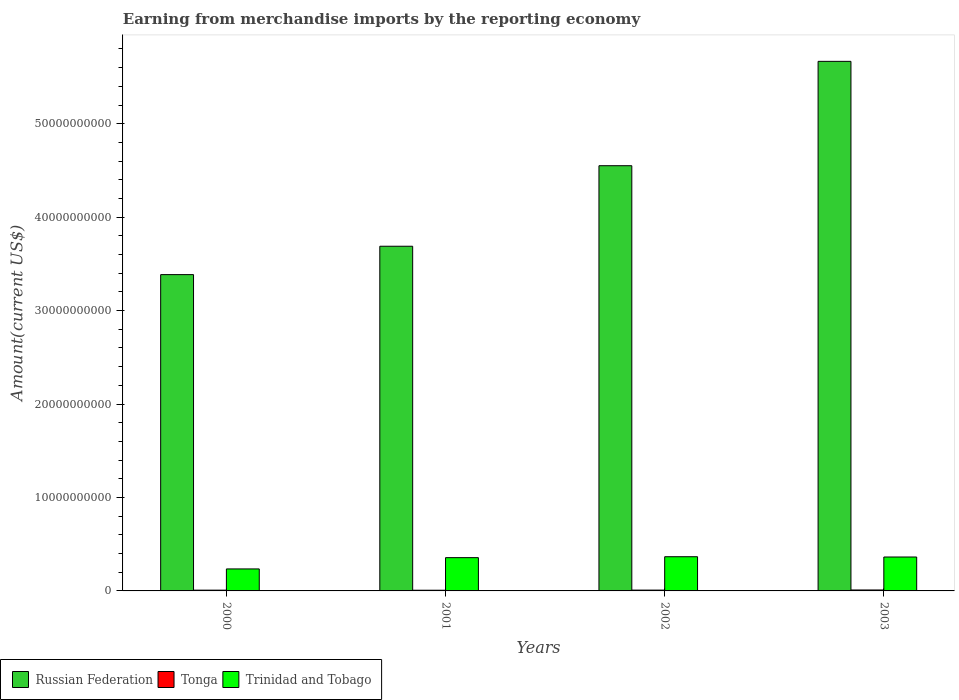How many different coloured bars are there?
Keep it short and to the point. 3. How many bars are there on the 4th tick from the left?
Make the answer very short. 3. What is the amount earned from merchandise imports in Tonga in 2002?
Provide a short and direct response. 8.71e+07. Across all years, what is the maximum amount earned from merchandise imports in Trinidad and Tobago?
Give a very brief answer. 3.66e+09. Across all years, what is the minimum amount earned from merchandise imports in Trinidad and Tobago?
Provide a short and direct response. 2.35e+09. What is the total amount earned from merchandise imports in Russian Federation in the graph?
Make the answer very short. 1.73e+11. What is the difference between the amount earned from merchandise imports in Tonga in 2002 and that in 2003?
Provide a succinct answer. -1.44e+07. What is the difference between the amount earned from merchandise imports in Trinidad and Tobago in 2001 and the amount earned from merchandise imports in Tonga in 2002?
Provide a succinct answer. 3.47e+09. What is the average amount earned from merchandise imports in Tonga per year?
Provide a succinct answer. 8.63e+07. In the year 2002, what is the difference between the amount earned from merchandise imports in Trinidad and Tobago and amount earned from merchandise imports in Tonga?
Ensure brevity in your answer.  3.57e+09. What is the ratio of the amount earned from merchandise imports in Tonga in 2002 to that in 2003?
Provide a succinct answer. 0.86. Is the difference between the amount earned from merchandise imports in Trinidad and Tobago in 2000 and 2003 greater than the difference between the amount earned from merchandise imports in Tonga in 2000 and 2003?
Provide a succinct answer. No. What is the difference between the highest and the second highest amount earned from merchandise imports in Trinidad and Tobago?
Provide a succinct answer. 3.12e+07. What is the difference between the highest and the lowest amount earned from merchandise imports in Trinidad and Tobago?
Offer a very short reply. 1.31e+09. In how many years, is the amount earned from merchandise imports in Trinidad and Tobago greater than the average amount earned from merchandise imports in Trinidad and Tobago taken over all years?
Make the answer very short. 3. Is the sum of the amount earned from merchandise imports in Russian Federation in 2001 and 2003 greater than the maximum amount earned from merchandise imports in Trinidad and Tobago across all years?
Your response must be concise. Yes. What does the 2nd bar from the left in 2001 represents?
Provide a short and direct response. Tonga. What does the 3rd bar from the right in 2000 represents?
Offer a very short reply. Russian Federation. Are all the bars in the graph horizontal?
Offer a very short reply. No. What is the difference between two consecutive major ticks on the Y-axis?
Offer a terse response. 1.00e+1. Are the values on the major ticks of Y-axis written in scientific E-notation?
Give a very brief answer. No. What is the title of the graph?
Your answer should be compact. Earning from merchandise imports by the reporting economy. What is the label or title of the X-axis?
Your answer should be compact. Years. What is the label or title of the Y-axis?
Keep it short and to the point. Amount(current US$). What is the Amount(current US$) of Russian Federation in 2000?
Your answer should be very brief. 3.39e+1. What is the Amount(current US$) of Tonga in 2000?
Offer a very short reply. 8.27e+07. What is the Amount(current US$) in Trinidad and Tobago in 2000?
Offer a very short reply. 2.35e+09. What is the Amount(current US$) in Russian Federation in 2001?
Provide a succinct answer. 3.69e+1. What is the Amount(current US$) in Tonga in 2001?
Provide a succinct answer. 7.39e+07. What is the Amount(current US$) of Trinidad and Tobago in 2001?
Offer a terse response. 3.56e+09. What is the Amount(current US$) of Russian Federation in 2002?
Offer a very short reply. 4.55e+1. What is the Amount(current US$) of Tonga in 2002?
Keep it short and to the point. 8.71e+07. What is the Amount(current US$) of Trinidad and Tobago in 2002?
Your response must be concise. 3.66e+09. What is the Amount(current US$) of Russian Federation in 2003?
Give a very brief answer. 5.67e+1. What is the Amount(current US$) in Tonga in 2003?
Keep it short and to the point. 1.01e+08. What is the Amount(current US$) in Trinidad and Tobago in 2003?
Your answer should be compact. 3.63e+09. Across all years, what is the maximum Amount(current US$) in Russian Federation?
Keep it short and to the point. 5.67e+1. Across all years, what is the maximum Amount(current US$) of Tonga?
Give a very brief answer. 1.01e+08. Across all years, what is the maximum Amount(current US$) of Trinidad and Tobago?
Your answer should be very brief. 3.66e+09. Across all years, what is the minimum Amount(current US$) in Russian Federation?
Ensure brevity in your answer.  3.39e+1. Across all years, what is the minimum Amount(current US$) of Tonga?
Give a very brief answer. 7.39e+07. Across all years, what is the minimum Amount(current US$) of Trinidad and Tobago?
Your response must be concise. 2.35e+09. What is the total Amount(current US$) in Russian Federation in the graph?
Provide a succinct answer. 1.73e+11. What is the total Amount(current US$) of Tonga in the graph?
Make the answer very short. 3.45e+08. What is the total Amount(current US$) of Trinidad and Tobago in the graph?
Ensure brevity in your answer.  1.32e+1. What is the difference between the Amount(current US$) in Russian Federation in 2000 and that in 2001?
Keep it short and to the point. -3.04e+09. What is the difference between the Amount(current US$) in Tonga in 2000 and that in 2001?
Your answer should be very brief. 8.82e+06. What is the difference between the Amount(current US$) of Trinidad and Tobago in 2000 and that in 2001?
Provide a succinct answer. -1.21e+09. What is the difference between the Amount(current US$) in Russian Federation in 2000 and that in 2002?
Keep it short and to the point. -1.17e+1. What is the difference between the Amount(current US$) in Tonga in 2000 and that in 2002?
Keep it short and to the point. -4.36e+06. What is the difference between the Amount(current US$) of Trinidad and Tobago in 2000 and that in 2002?
Your answer should be compact. -1.31e+09. What is the difference between the Amount(current US$) in Russian Federation in 2000 and that in 2003?
Offer a very short reply. -2.28e+1. What is the difference between the Amount(current US$) of Tonga in 2000 and that in 2003?
Make the answer very short. -1.88e+07. What is the difference between the Amount(current US$) of Trinidad and Tobago in 2000 and that in 2003?
Your answer should be compact. -1.28e+09. What is the difference between the Amount(current US$) of Russian Federation in 2001 and that in 2002?
Your response must be concise. -8.62e+09. What is the difference between the Amount(current US$) of Tonga in 2001 and that in 2002?
Provide a short and direct response. -1.32e+07. What is the difference between the Amount(current US$) in Trinidad and Tobago in 2001 and that in 2002?
Ensure brevity in your answer.  -9.90e+07. What is the difference between the Amount(current US$) in Russian Federation in 2001 and that in 2003?
Provide a succinct answer. -1.98e+1. What is the difference between the Amount(current US$) of Tonga in 2001 and that in 2003?
Your answer should be very brief. -2.76e+07. What is the difference between the Amount(current US$) of Trinidad and Tobago in 2001 and that in 2003?
Provide a short and direct response. -6.78e+07. What is the difference between the Amount(current US$) of Russian Federation in 2002 and that in 2003?
Your answer should be compact. -1.12e+1. What is the difference between the Amount(current US$) of Tonga in 2002 and that in 2003?
Ensure brevity in your answer.  -1.44e+07. What is the difference between the Amount(current US$) in Trinidad and Tobago in 2002 and that in 2003?
Keep it short and to the point. 3.12e+07. What is the difference between the Amount(current US$) of Russian Federation in 2000 and the Amount(current US$) of Tonga in 2001?
Ensure brevity in your answer.  3.38e+1. What is the difference between the Amount(current US$) in Russian Federation in 2000 and the Amount(current US$) in Trinidad and Tobago in 2001?
Offer a terse response. 3.03e+1. What is the difference between the Amount(current US$) of Tonga in 2000 and the Amount(current US$) of Trinidad and Tobago in 2001?
Provide a succinct answer. -3.48e+09. What is the difference between the Amount(current US$) in Russian Federation in 2000 and the Amount(current US$) in Tonga in 2002?
Offer a very short reply. 3.38e+1. What is the difference between the Amount(current US$) of Russian Federation in 2000 and the Amount(current US$) of Trinidad and Tobago in 2002?
Offer a terse response. 3.02e+1. What is the difference between the Amount(current US$) in Tonga in 2000 and the Amount(current US$) in Trinidad and Tobago in 2002?
Give a very brief answer. -3.58e+09. What is the difference between the Amount(current US$) in Russian Federation in 2000 and the Amount(current US$) in Tonga in 2003?
Your response must be concise. 3.38e+1. What is the difference between the Amount(current US$) in Russian Federation in 2000 and the Amount(current US$) in Trinidad and Tobago in 2003?
Provide a short and direct response. 3.02e+1. What is the difference between the Amount(current US$) of Tonga in 2000 and the Amount(current US$) of Trinidad and Tobago in 2003?
Ensure brevity in your answer.  -3.55e+09. What is the difference between the Amount(current US$) of Russian Federation in 2001 and the Amount(current US$) of Tonga in 2002?
Provide a short and direct response. 3.68e+1. What is the difference between the Amount(current US$) in Russian Federation in 2001 and the Amount(current US$) in Trinidad and Tobago in 2002?
Make the answer very short. 3.32e+1. What is the difference between the Amount(current US$) of Tonga in 2001 and the Amount(current US$) of Trinidad and Tobago in 2002?
Your response must be concise. -3.59e+09. What is the difference between the Amount(current US$) in Russian Federation in 2001 and the Amount(current US$) in Tonga in 2003?
Make the answer very short. 3.68e+1. What is the difference between the Amount(current US$) of Russian Federation in 2001 and the Amount(current US$) of Trinidad and Tobago in 2003?
Your answer should be compact. 3.33e+1. What is the difference between the Amount(current US$) in Tonga in 2001 and the Amount(current US$) in Trinidad and Tobago in 2003?
Provide a succinct answer. -3.56e+09. What is the difference between the Amount(current US$) of Russian Federation in 2002 and the Amount(current US$) of Tonga in 2003?
Keep it short and to the point. 4.54e+1. What is the difference between the Amount(current US$) in Russian Federation in 2002 and the Amount(current US$) in Trinidad and Tobago in 2003?
Keep it short and to the point. 4.19e+1. What is the difference between the Amount(current US$) in Tonga in 2002 and the Amount(current US$) in Trinidad and Tobago in 2003?
Make the answer very short. -3.54e+09. What is the average Amount(current US$) of Russian Federation per year?
Your answer should be very brief. 4.32e+1. What is the average Amount(current US$) in Tonga per year?
Make the answer very short. 8.63e+07. What is the average Amount(current US$) in Trinidad and Tobago per year?
Your response must be concise. 3.30e+09. In the year 2000, what is the difference between the Amount(current US$) in Russian Federation and Amount(current US$) in Tonga?
Keep it short and to the point. 3.38e+1. In the year 2000, what is the difference between the Amount(current US$) of Russian Federation and Amount(current US$) of Trinidad and Tobago?
Your answer should be very brief. 3.15e+1. In the year 2000, what is the difference between the Amount(current US$) in Tonga and Amount(current US$) in Trinidad and Tobago?
Keep it short and to the point. -2.27e+09. In the year 2001, what is the difference between the Amount(current US$) in Russian Federation and Amount(current US$) in Tonga?
Make the answer very short. 3.68e+1. In the year 2001, what is the difference between the Amount(current US$) in Russian Federation and Amount(current US$) in Trinidad and Tobago?
Keep it short and to the point. 3.33e+1. In the year 2001, what is the difference between the Amount(current US$) of Tonga and Amount(current US$) of Trinidad and Tobago?
Make the answer very short. -3.49e+09. In the year 2002, what is the difference between the Amount(current US$) in Russian Federation and Amount(current US$) in Tonga?
Offer a very short reply. 4.54e+1. In the year 2002, what is the difference between the Amount(current US$) in Russian Federation and Amount(current US$) in Trinidad and Tobago?
Keep it short and to the point. 4.18e+1. In the year 2002, what is the difference between the Amount(current US$) of Tonga and Amount(current US$) of Trinidad and Tobago?
Make the answer very short. -3.57e+09. In the year 2003, what is the difference between the Amount(current US$) of Russian Federation and Amount(current US$) of Tonga?
Make the answer very short. 5.66e+1. In the year 2003, what is the difference between the Amount(current US$) in Russian Federation and Amount(current US$) in Trinidad and Tobago?
Make the answer very short. 5.30e+1. In the year 2003, what is the difference between the Amount(current US$) of Tonga and Amount(current US$) of Trinidad and Tobago?
Make the answer very short. -3.53e+09. What is the ratio of the Amount(current US$) in Russian Federation in 2000 to that in 2001?
Offer a very short reply. 0.92. What is the ratio of the Amount(current US$) in Tonga in 2000 to that in 2001?
Keep it short and to the point. 1.12. What is the ratio of the Amount(current US$) in Trinidad and Tobago in 2000 to that in 2001?
Keep it short and to the point. 0.66. What is the ratio of the Amount(current US$) of Russian Federation in 2000 to that in 2002?
Ensure brevity in your answer.  0.74. What is the ratio of the Amount(current US$) of Trinidad and Tobago in 2000 to that in 2002?
Provide a short and direct response. 0.64. What is the ratio of the Amount(current US$) in Russian Federation in 2000 to that in 2003?
Provide a succinct answer. 0.6. What is the ratio of the Amount(current US$) of Tonga in 2000 to that in 2003?
Ensure brevity in your answer.  0.82. What is the ratio of the Amount(current US$) of Trinidad and Tobago in 2000 to that in 2003?
Your answer should be compact. 0.65. What is the ratio of the Amount(current US$) of Russian Federation in 2001 to that in 2002?
Offer a very short reply. 0.81. What is the ratio of the Amount(current US$) in Tonga in 2001 to that in 2002?
Your response must be concise. 0.85. What is the ratio of the Amount(current US$) of Russian Federation in 2001 to that in 2003?
Keep it short and to the point. 0.65. What is the ratio of the Amount(current US$) in Tonga in 2001 to that in 2003?
Your response must be concise. 0.73. What is the ratio of the Amount(current US$) in Trinidad and Tobago in 2001 to that in 2003?
Offer a terse response. 0.98. What is the ratio of the Amount(current US$) of Russian Federation in 2002 to that in 2003?
Offer a terse response. 0.8. What is the ratio of the Amount(current US$) of Tonga in 2002 to that in 2003?
Ensure brevity in your answer.  0.86. What is the ratio of the Amount(current US$) in Trinidad and Tobago in 2002 to that in 2003?
Make the answer very short. 1.01. What is the difference between the highest and the second highest Amount(current US$) of Russian Federation?
Provide a succinct answer. 1.12e+1. What is the difference between the highest and the second highest Amount(current US$) of Tonga?
Your response must be concise. 1.44e+07. What is the difference between the highest and the second highest Amount(current US$) in Trinidad and Tobago?
Provide a succinct answer. 3.12e+07. What is the difference between the highest and the lowest Amount(current US$) of Russian Federation?
Keep it short and to the point. 2.28e+1. What is the difference between the highest and the lowest Amount(current US$) of Tonga?
Ensure brevity in your answer.  2.76e+07. What is the difference between the highest and the lowest Amount(current US$) of Trinidad and Tobago?
Provide a succinct answer. 1.31e+09. 